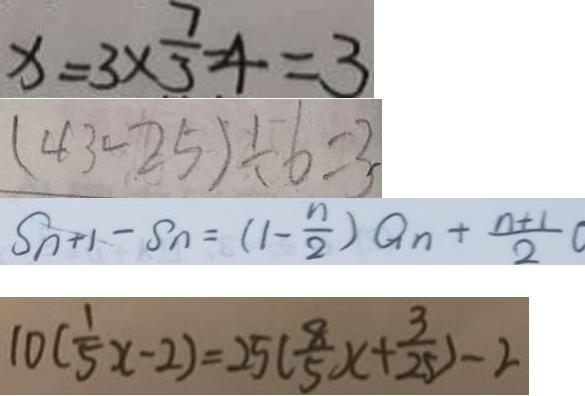Convert formula to latex. <formula><loc_0><loc_0><loc_500><loc_500>x = 3 \times \frac { 7 } { 3 } - 4 = 3 
 ( 4 3 - 2 5 ) \div 6 = 3 
 S _ { n + 1 } - S n = ( 1 - \frac { n } { 2 } ) Q _ { n } + \frac { n + 1 } { 2 } 
 1 0 ( \frac { 1 } { 5 } x - 2 ) = 2 5 ( \frac { 8 } { 5 } x + \frac { 3 } { 2 5 } ) - 2</formula> 